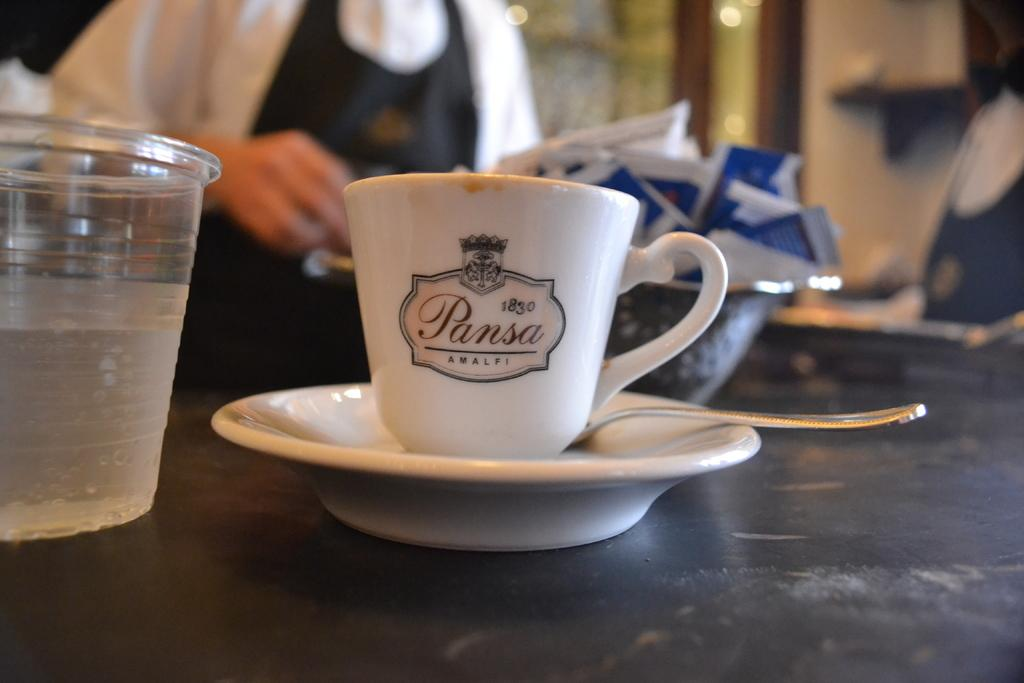Who or what is in the image? There is a person in the image. Where is the person located in relation to other objects? The person is in front of a table. What can be seen on the table? There are objects placed on the table. What type of button can be seen being pressed by the person in the image? There is no button present in the image, and the person is not shown pressing anything. 